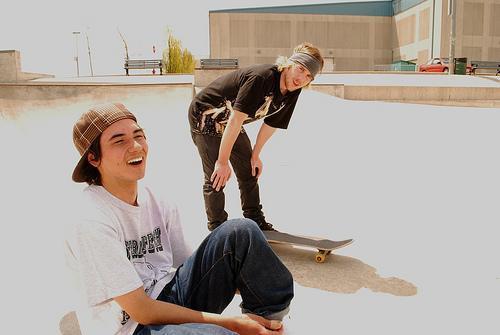How many people are in the picture?
Give a very brief answer. 2. 